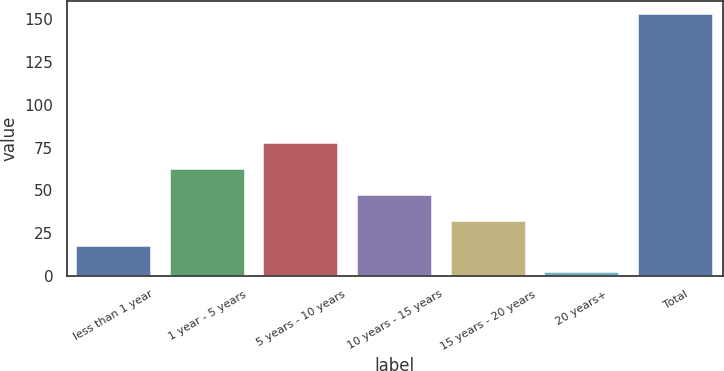Convert chart. <chart><loc_0><loc_0><loc_500><loc_500><bar_chart><fcel>less than 1 year<fcel>1 year - 5 years<fcel>5 years - 10 years<fcel>10 years - 15 years<fcel>15 years - 20 years<fcel>20 years+<fcel>Total<nl><fcel>17.27<fcel>62.48<fcel>77.55<fcel>47.41<fcel>32.34<fcel>2.2<fcel>152.9<nl></chart> 